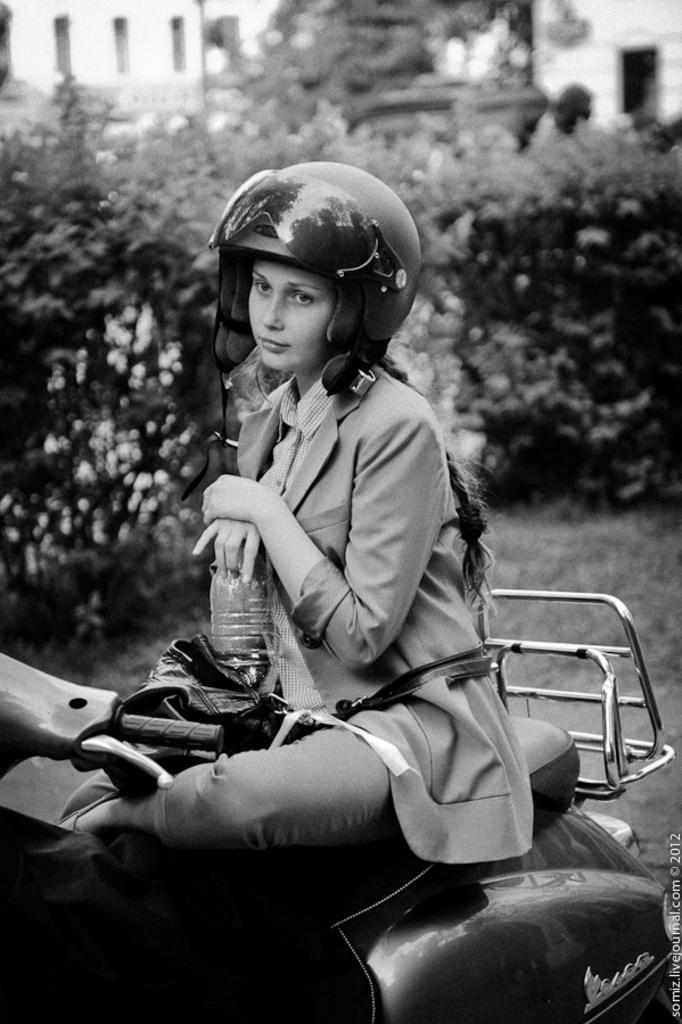Please provide a concise description of this image. In this picture we can see a woman sitting on the motorcycle, and holding a bottle in her hands, and at back here are the trees. 